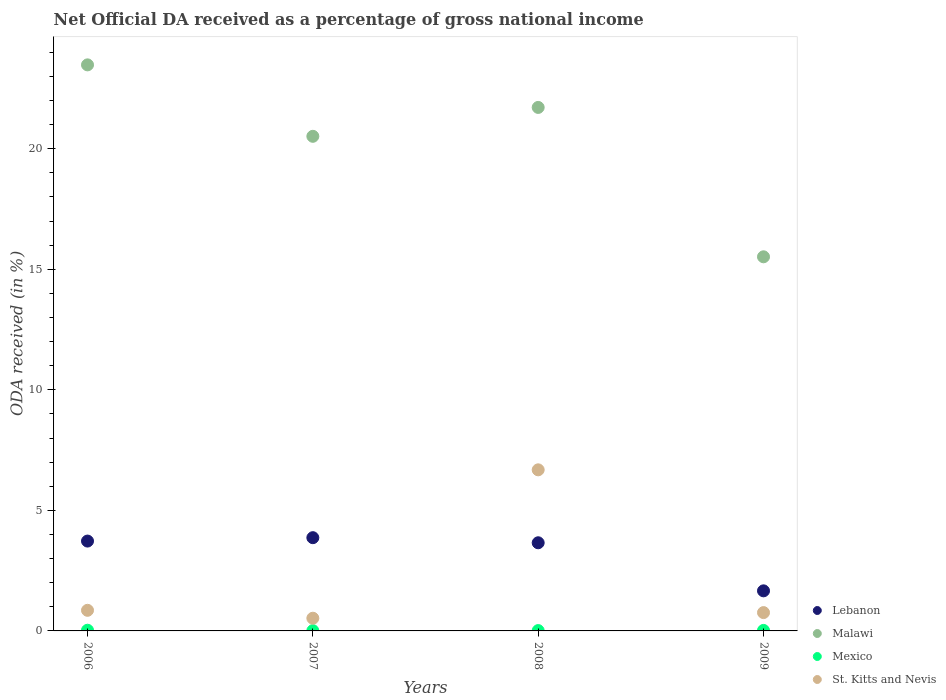What is the net official DA received in Mexico in 2008?
Give a very brief answer. 0.01. Across all years, what is the maximum net official DA received in St. Kitts and Nevis?
Provide a succinct answer. 6.68. Across all years, what is the minimum net official DA received in St. Kitts and Nevis?
Provide a succinct answer. 0.53. In which year was the net official DA received in Lebanon minimum?
Offer a very short reply. 2009. What is the total net official DA received in Lebanon in the graph?
Provide a succinct answer. 12.91. What is the difference between the net official DA received in Malawi in 2006 and that in 2008?
Your response must be concise. 1.77. What is the difference between the net official DA received in Lebanon in 2006 and the net official DA received in Malawi in 2008?
Offer a terse response. -17.98. What is the average net official DA received in Lebanon per year?
Offer a terse response. 3.23. In the year 2008, what is the difference between the net official DA received in Mexico and net official DA received in Lebanon?
Offer a very short reply. -3.64. In how many years, is the net official DA received in Malawi greater than 12 %?
Your answer should be compact. 4. What is the ratio of the net official DA received in Mexico in 2007 to that in 2009?
Offer a very short reply. 0.53. Is the net official DA received in Mexico in 2007 less than that in 2008?
Offer a very short reply. Yes. What is the difference between the highest and the second highest net official DA received in St. Kitts and Nevis?
Provide a succinct answer. 5.83. What is the difference between the highest and the lowest net official DA received in Lebanon?
Your answer should be very brief. 2.2. Is it the case that in every year, the sum of the net official DA received in Malawi and net official DA received in Lebanon  is greater than the sum of net official DA received in Mexico and net official DA received in St. Kitts and Nevis?
Your answer should be compact. Yes. Does the net official DA received in St. Kitts and Nevis monotonically increase over the years?
Give a very brief answer. No. Is the net official DA received in St. Kitts and Nevis strictly less than the net official DA received in Mexico over the years?
Provide a succinct answer. No. How many dotlines are there?
Your response must be concise. 4. What is the difference between two consecutive major ticks on the Y-axis?
Offer a terse response. 5. Are the values on the major ticks of Y-axis written in scientific E-notation?
Provide a short and direct response. No. Does the graph contain any zero values?
Give a very brief answer. No. Where does the legend appear in the graph?
Offer a very short reply. Bottom right. What is the title of the graph?
Offer a very short reply. Net Official DA received as a percentage of gross national income. Does "Bosnia and Herzegovina" appear as one of the legend labels in the graph?
Provide a short and direct response. No. What is the label or title of the X-axis?
Keep it short and to the point. Years. What is the label or title of the Y-axis?
Your response must be concise. ODA received (in %). What is the ODA received (in %) in Lebanon in 2006?
Your response must be concise. 3.73. What is the ODA received (in %) in Malawi in 2006?
Your answer should be compact. 23.48. What is the ODA received (in %) in Mexico in 2006?
Your answer should be very brief. 0.03. What is the ODA received (in %) of St. Kitts and Nevis in 2006?
Ensure brevity in your answer.  0.85. What is the ODA received (in %) in Lebanon in 2007?
Offer a very short reply. 3.87. What is the ODA received (in %) in Malawi in 2007?
Ensure brevity in your answer.  20.51. What is the ODA received (in %) in Mexico in 2007?
Offer a very short reply. 0.01. What is the ODA received (in %) in St. Kitts and Nevis in 2007?
Your answer should be compact. 0.53. What is the ODA received (in %) of Lebanon in 2008?
Provide a short and direct response. 3.66. What is the ODA received (in %) in Malawi in 2008?
Your answer should be compact. 21.71. What is the ODA received (in %) of Mexico in 2008?
Offer a very short reply. 0.01. What is the ODA received (in %) of St. Kitts and Nevis in 2008?
Give a very brief answer. 6.68. What is the ODA received (in %) in Lebanon in 2009?
Provide a short and direct response. 1.66. What is the ODA received (in %) in Malawi in 2009?
Provide a succinct answer. 15.52. What is the ODA received (in %) of Mexico in 2009?
Your response must be concise. 0.02. What is the ODA received (in %) in St. Kitts and Nevis in 2009?
Make the answer very short. 0.76. Across all years, what is the maximum ODA received (in %) in Lebanon?
Keep it short and to the point. 3.87. Across all years, what is the maximum ODA received (in %) of Malawi?
Your response must be concise. 23.48. Across all years, what is the maximum ODA received (in %) of Mexico?
Provide a short and direct response. 0.03. Across all years, what is the maximum ODA received (in %) in St. Kitts and Nevis?
Provide a short and direct response. 6.68. Across all years, what is the minimum ODA received (in %) in Lebanon?
Make the answer very short. 1.66. Across all years, what is the minimum ODA received (in %) in Malawi?
Your answer should be compact. 15.52. Across all years, what is the minimum ODA received (in %) of Mexico?
Your answer should be very brief. 0.01. Across all years, what is the minimum ODA received (in %) of St. Kitts and Nevis?
Your response must be concise. 0.53. What is the total ODA received (in %) in Lebanon in the graph?
Give a very brief answer. 12.91. What is the total ODA received (in %) in Malawi in the graph?
Offer a terse response. 81.21. What is the total ODA received (in %) of Mexico in the graph?
Make the answer very short. 0.07. What is the total ODA received (in %) in St. Kitts and Nevis in the graph?
Your answer should be very brief. 8.82. What is the difference between the ODA received (in %) in Lebanon in 2006 and that in 2007?
Your answer should be compact. -0.14. What is the difference between the ODA received (in %) in Malawi in 2006 and that in 2007?
Offer a terse response. 2.96. What is the difference between the ODA received (in %) of Mexico in 2006 and that in 2007?
Ensure brevity in your answer.  0.02. What is the difference between the ODA received (in %) of St. Kitts and Nevis in 2006 and that in 2007?
Give a very brief answer. 0.33. What is the difference between the ODA received (in %) of Lebanon in 2006 and that in 2008?
Give a very brief answer. 0.07. What is the difference between the ODA received (in %) in Malawi in 2006 and that in 2008?
Keep it short and to the point. 1.77. What is the difference between the ODA received (in %) in Mexico in 2006 and that in 2008?
Offer a terse response. 0.01. What is the difference between the ODA received (in %) in St. Kitts and Nevis in 2006 and that in 2008?
Provide a succinct answer. -5.83. What is the difference between the ODA received (in %) in Lebanon in 2006 and that in 2009?
Your response must be concise. 2.06. What is the difference between the ODA received (in %) in Malawi in 2006 and that in 2009?
Your answer should be compact. 7.96. What is the difference between the ODA received (in %) in Mexico in 2006 and that in 2009?
Your answer should be very brief. 0.01. What is the difference between the ODA received (in %) of St. Kitts and Nevis in 2006 and that in 2009?
Offer a very short reply. 0.09. What is the difference between the ODA received (in %) in Lebanon in 2007 and that in 2008?
Ensure brevity in your answer.  0.21. What is the difference between the ODA received (in %) in Malawi in 2007 and that in 2008?
Your response must be concise. -1.2. What is the difference between the ODA received (in %) in Mexico in 2007 and that in 2008?
Provide a succinct answer. -0. What is the difference between the ODA received (in %) of St. Kitts and Nevis in 2007 and that in 2008?
Offer a terse response. -6.15. What is the difference between the ODA received (in %) of Lebanon in 2007 and that in 2009?
Give a very brief answer. 2.2. What is the difference between the ODA received (in %) in Malawi in 2007 and that in 2009?
Your answer should be compact. 5. What is the difference between the ODA received (in %) of Mexico in 2007 and that in 2009?
Offer a terse response. -0.01. What is the difference between the ODA received (in %) of St. Kitts and Nevis in 2007 and that in 2009?
Keep it short and to the point. -0.23. What is the difference between the ODA received (in %) in Lebanon in 2008 and that in 2009?
Your answer should be very brief. 1.99. What is the difference between the ODA received (in %) in Malawi in 2008 and that in 2009?
Your answer should be compact. 6.19. What is the difference between the ODA received (in %) in Mexico in 2008 and that in 2009?
Ensure brevity in your answer.  -0.01. What is the difference between the ODA received (in %) of St. Kitts and Nevis in 2008 and that in 2009?
Offer a very short reply. 5.92. What is the difference between the ODA received (in %) of Lebanon in 2006 and the ODA received (in %) of Malawi in 2007?
Your response must be concise. -16.79. What is the difference between the ODA received (in %) in Lebanon in 2006 and the ODA received (in %) in Mexico in 2007?
Your response must be concise. 3.72. What is the difference between the ODA received (in %) in Lebanon in 2006 and the ODA received (in %) in St. Kitts and Nevis in 2007?
Give a very brief answer. 3.2. What is the difference between the ODA received (in %) in Malawi in 2006 and the ODA received (in %) in Mexico in 2007?
Your answer should be very brief. 23.46. What is the difference between the ODA received (in %) of Malawi in 2006 and the ODA received (in %) of St. Kitts and Nevis in 2007?
Give a very brief answer. 22.95. What is the difference between the ODA received (in %) of Mexico in 2006 and the ODA received (in %) of St. Kitts and Nevis in 2007?
Ensure brevity in your answer.  -0.5. What is the difference between the ODA received (in %) of Lebanon in 2006 and the ODA received (in %) of Malawi in 2008?
Provide a succinct answer. -17.98. What is the difference between the ODA received (in %) of Lebanon in 2006 and the ODA received (in %) of Mexico in 2008?
Provide a short and direct response. 3.71. What is the difference between the ODA received (in %) in Lebanon in 2006 and the ODA received (in %) in St. Kitts and Nevis in 2008?
Offer a very short reply. -2.95. What is the difference between the ODA received (in %) of Malawi in 2006 and the ODA received (in %) of Mexico in 2008?
Offer a very short reply. 23.46. What is the difference between the ODA received (in %) of Malawi in 2006 and the ODA received (in %) of St. Kitts and Nevis in 2008?
Your answer should be compact. 16.79. What is the difference between the ODA received (in %) in Mexico in 2006 and the ODA received (in %) in St. Kitts and Nevis in 2008?
Offer a terse response. -6.65. What is the difference between the ODA received (in %) in Lebanon in 2006 and the ODA received (in %) in Malawi in 2009?
Your answer should be compact. -11.79. What is the difference between the ODA received (in %) in Lebanon in 2006 and the ODA received (in %) in Mexico in 2009?
Your answer should be compact. 3.71. What is the difference between the ODA received (in %) of Lebanon in 2006 and the ODA received (in %) of St. Kitts and Nevis in 2009?
Make the answer very short. 2.97. What is the difference between the ODA received (in %) of Malawi in 2006 and the ODA received (in %) of Mexico in 2009?
Keep it short and to the point. 23.45. What is the difference between the ODA received (in %) of Malawi in 2006 and the ODA received (in %) of St. Kitts and Nevis in 2009?
Your answer should be very brief. 22.72. What is the difference between the ODA received (in %) in Mexico in 2006 and the ODA received (in %) in St. Kitts and Nevis in 2009?
Your answer should be very brief. -0.73. What is the difference between the ODA received (in %) in Lebanon in 2007 and the ODA received (in %) in Malawi in 2008?
Keep it short and to the point. -17.84. What is the difference between the ODA received (in %) of Lebanon in 2007 and the ODA received (in %) of Mexico in 2008?
Make the answer very short. 3.85. What is the difference between the ODA received (in %) in Lebanon in 2007 and the ODA received (in %) in St. Kitts and Nevis in 2008?
Your answer should be very brief. -2.81. What is the difference between the ODA received (in %) in Malawi in 2007 and the ODA received (in %) in Mexico in 2008?
Offer a very short reply. 20.5. What is the difference between the ODA received (in %) in Malawi in 2007 and the ODA received (in %) in St. Kitts and Nevis in 2008?
Provide a succinct answer. 13.83. What is the difference between the ODA received (in %) of Mexico in 2007 and the ODA received (in %) of St. Kitts and Nevis in 2008?
Your response must be concise. -6.67. What is the difference between the ODA received (in %) of Lebanon in 2007 and the ODA received (in %) of Malawi in 2009?
Your answer should be compact. -11.65. What is the difference between the ODA received (in %) in Lebanon in 2007 and the ODA received (in %) in Mexico in 2009?
Ensure brevity in your answer.  3.85. What is the difference between the ODA received (in %) of Lebanon in 2007 and the ODA received (in %) of St. Kitts and Nevis in 2009?
Ensure brevity in your answer.  3.11. What is the difference between the ODA received (in %) of Malawi in 2007 and the ODA received (in %) of Mexico in 2009?
Give a very brief answer. 20.49. What is the difference between the ODA received (in %) in Malawi in 2007 and the ODA received (in %) in St. Kitts and Nevis in 2009?
Make the answer very short. 19.75. What is the difference between the ODA received (in %) of Mexico in 2007 and the ODA received (in %) of St. Kitts and Nevis in 2009?
Offer a terse response. -0.75. What is the difference between the ODA received (in %) in Lebanon in 2008 and the ODA received (in %) in Malawi in 2009?
Your response must be concise. -11.86. What is the difference between the ODA received (in %) in Lebanon in 2008 and the ODA received (in %) in Mexico in 2009?
Make the answer very short. 3.63. What is the difference between the ODA received (in %) in Lebanon in 2008 and the ODA received (in %) in St. Kitts and Nevis in 2009?
Your answer should be very brief. 2.9. What is the difference between the ODA received (in %) in Malawi in 2008 and the ODA received (in %) in Mexico in 2009?
Keep it short and to the point. 21.69. What is the difference between the ODA received (in %) in Malawi in 2008 and the ODA received (in %) in St. Kitts and Nevis in 2009?
Ensure brevity in your answer.  20.95. What is the difference between the ODA received (in %) in Mexico in 2008 and the ODA received (in %) in St. Kitts and Nevis in 2009?
Your response must be concise. -0.75. What is the average ODA received (in %) of Lebanon per year?
Offer a very short reply. 3.23. What is the average ODA received (in %) of Malawi per year?
Your response must be concise. 20.3. What is the average ODA received (in %) in Mexico per year?
Ensure brevity in your answer.  0.02. What is the average ODA received (in %) of St. Kitts and Nevis per year?
Offer a very short reply. 2.21. In the year 2006, what is the difference between the ODA received (in %) of Lebanon and ODA received (in %) of Malawi?
Provide a short and direct response. -19.75. In the year 2006, what is the difference between the ODA received (in %) in Lebanon and ODA received (in %) in Mexico?
Your answer should be very brief. 3.7. In the year 2006, what is the difference between the ODA received (in %) in Lebanon and ODA received (in %) in St. Kitts and Nevis?
Your response must be concise. 2.87. In the year 2006, what is the difference between the ODA received (in %) in Malawi and ODA received (in %) in Mexico?
Provide a succinct answer. 23.45. In the year 2006, what is the difference between the ODA received (in %) of Malawi and ODA received (in %) of St. Kitts and Nevis?
Your answer should be compact. 22.62. In the year 2006, what is the difference between the ODA received (in %) in Mexico and ODA received (in %) in St. Kitts and Nevis?
Provide a succinct answer. -0.83. In the year 2007, what is the difference between the ODA received (in %) in Lebanon and ODA received (in %) in Malawi?
Offer a very short reply. -16.65. In the year 2007, what is the difference between the ODA received (in %) in Lebanon and ODA received (in %) in Mexico?
Make the answer very short. 3.86. In the year 2007, what is the difference between the ODA received (in %) of Lebanon and ODA received (in %) of St. Kitts and Nevis?
Make the answer very short. 3.34. In the year 2007, what is the difference between the ODA received (in %) of Malawi and ODA received (in %) of Mexico?
Provide a short and direct response. 20.5. In the year 2007, what is the difference between the ODA received (in %) of Malawi and ODA received (in %) of St. Kitts and Nevis?
Keep it short and to the point. 19.99. In the year 2007, what is the difference between the ODA received (in %) of Mexico and ODA received (in %) of St. Kitts and Nevis?
Offer a terse response. -0.52. In the year 2008, what is the difference between the ODA received (in %) of Lebanon and ODA received (in %) of Malawi?
Your response must be concise. -18.05. In the year 2008, what is the difference between the ODA received (in %) of Lebanon and ODA received (in %) of Mexico?
Offer a terse response. 3.64. In the year 2008, what is the difference between the ODA received (in %) of Lebanon and ODA received (in %) of St. Kitts and Nevis?
Give a very brief answer. -3.03. In the year 2008, what is the difference between the ODA received (in %) in Malawi and ODA received (in %) in Mexico?
Your answer should be compact. 21.7. In the year 2008, what is the difference between the ODA received (in %) of Malawi and ODA received (in %) of St. Kitts and Nevis?
Give a very brief answer. 15.03. In the year 2008, what is the difference between the ODA received (in %) in Mexico and ODA received (in %) in St. Kitts and Nevis?
Give a very brief answer. -6.67. In the year 2009, what is the difference between the ODA received (in %) of Lebanon and ODA received (in %) of Malawi?
Make the answer very short. -13.85. In the year 2009, what is the difference between the ODA received (in %) in Lebanon and ODA received (in %) in Mexico?
Your answer should be very brief. 1.64. In the year 2009, what is the difference between the ODA received (in %) in Lebanon and ODA received (in %) in St. Kitts and Nevis?
Provide a succinct answer. 0.9. In the year 2009, what is the difference between the ODA received (in %) of Malawi and ODA received (in %) of Mexico?
Keep it short and to the point. 15.49. In the year 2009, what is the difference between the ODA received (in %) of Malawi and ODA received (in %) of St. Kitts and Nevis?
Offer a very short reply. 14.76. In the year 2009, what is the difference between the ODA received (in %) of Mexico and ODA received (in %) of St. Kitts and Nevis?
Give a very brief answer. -0.74. What is the ratio of the ODA received (in %) in Lebanon in 2006 to that in 2007?
Offer a terse response. 0.96. What is the ratio of the ODA received (in %) of Malawi in 2006 to that in 2007?
Offer a terse response. 1.14. What is the ratio of the ODA received (in %) of Mexico in 2006 to that in 2007?
Offer a terse response. 2.57. What is the ratio of the ODA received (in %) of St. Kitts and Nevis in 2006 to that in 2007?
Give a very brief answer. 1.62. What is the ratio of the ODA received (in %) of Lebanon in 2006 to that in 2008?
Ensure brevity in your answer.  1.02. What is the ratio of the ODA received (in %) in Malawi in 2006 to that in 2008?
Your answer should be compact. 1.08. What is the ratio of the ODA received (in %) of Mexico in 2006 to that in 2008?
Provide a short and direct response. 2.07. What is the ratio of the ODA received (in %) of St. Kitts and Nevis in 2006 to that in 2008?
Offer a terse response. 0.13. What is the ratio of the ODA received (in %) in Lebanon in 2006 to that in 2009?
Make the answer very short. 2.24. What is the ratio of the ODA received (in %) of Malawi in 2006 to that in 2009?
Your answer should be very brief. 1.51. What is the ratio of the ODA received (in %) in Mexico in 2006 to that in 2009?
Make the answer very short. 1.36. What is the ratio of the ODA received (in %) in St. Kitts and Nevis in 2006 to that in 2009?
Give a very brief answer. 1.12. What is the ratio of the ODA received (in %) in Lebanon in 2007 to that in 2008?
Give a very brief answer. 1.06. What is the ratio of the ODA received (in %) in Malawi in 2007 to that in 2008?
Keep it short and to the point. 0.94. What is the ratio of the ODA received (in %) of Mexico in 2007 to that in 2008?
Make the answer very short. 0.81. What is the ratio of the ODA received (in %) of St. Kitts and Nevis in 2007 to that in 2008?
Give a very brief answer. 0.08. What is the ratio of the ODA received (in %) in Lebanon in 2007 to that in 2009?
Give a very brief answer. 2.33. What is the ratio of the ODA received (in %) of Malawi in 2007 to that in 2009?
Provide a succinct answer. 1.32. What is the ratio of the ODA received (in %) in Mexico in 2007 to that in 2009?
Your answer should be very brief. 0.53. What is the ratio of the ODA received (in %) in St. Kitts and Nevis in 2007 to that in 2009?
Offer a very short reply. 0.69. What is the ratio of the ODA received (in %) in Lebanon in 2008 to that in 2009?
Your answer should be very brief. 2.2. What is the ratio of the ODA received (in %) in Malawi in 2008 to that in 2009?
Offer a terse response. 1.4. What is the ratio of the ODA received (in %) in Mexico in 2008 to that in 2009?
Your response must be concise. 0.66. What is the ratio of the ODA received (in %) in St. Kitts and Nevis in 2008 to that in 2009?
Provide a succinct answer. 8.79. What is the difference between the highest and the second highest ODA received (in %) of Lebanon?
Provide a succinct answer. 0.14. What is the difference between the highest and the second highest ODA received (in %) in Malawi?
Ensure brevity in your answer.  1.77. What is the difference between the highest and the second highest ODA received (in %) in Mexico?
Keep it short and to the point. 0.01. What is the difference between the highest and the second highest ODA received (in %) of St. Kitts and Nevis?
Your answer should be very brief. 5.83. What is the difference between the highest and the lowest ODA received (in %) in Lebanon?
Ensure brevity in your answer.  2.2. What is the difference between the highest and the lowest ODA received (in %) in Malawi?
Make the answer very short. 7.96. What is the difference between the highest and the lowest ODA received (in %) in Mexico?
Your answer should be compact. 0.02. What is the difference between the highest and the lowest ODA received (in %) in St. Kitts and Nevis?
Your answer should be very brief. 6.15. 